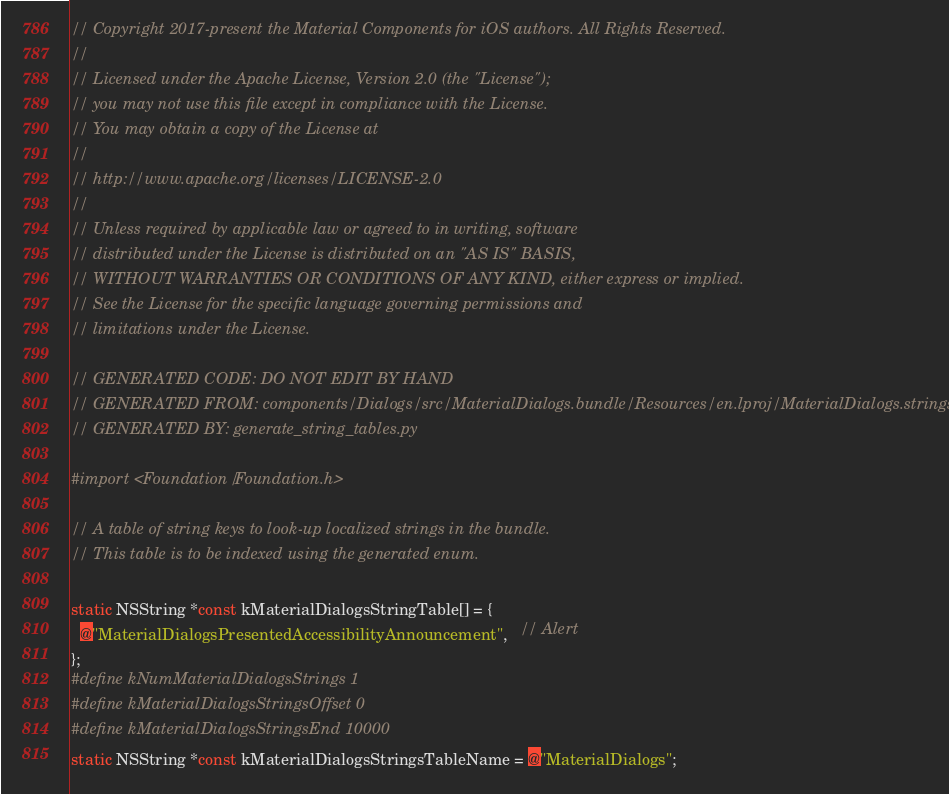<code> <loc_0><loc_0><loc_500><loc_500><_C_>// Copyright 2017-present the Material Components for iOS authors. All Rights Reserved.
//
// Licensed under the Apache License, Version 2.0 (the "License");
// you may not use this file except in compliance with the License.
// You may obtain a copy of the License at
//
// http://www.apache.org/licenses/LICENSE-2.0
//
// Unless required by applicable law or agreed to in writing, software
// distributed under the License is distributed on an "AS IS" BASIS,
// WITHOUT WARRANTIES OR CONDITIONS OF ANY KIND, either express or implied.
// See the License for the specific language governing permissions and
// limitations under the License.

// GENERATED CODE: DO NOT EDIT BY HAND
// GENERATED FROM: components/Dialogs/src/MaterialDialogs.bundle/Resources/en.lproj/MaterialDialogs.strings
// GENERATED BY: generate_string_tables.py

#import <Foundation/Foundation.h>

// A table of string keys to look-up localized strings in the bundle.
// This table is to be indexed using the generated enum.

static NSString *const kMaterialDialogsStringTable[] = {
  @"MaterialDialogsPresentedAccessibilityAnnouncement",   // Alert
};
#define kNumMaterialDialogsStrings 1
#define kMaterialDialogsStringsOffset 0
#define kMaterialDialogsStringsEnd 10000
static NSString *const kMaterialDialogsStringsTableName = @"MaterialDialogs";
</code> 